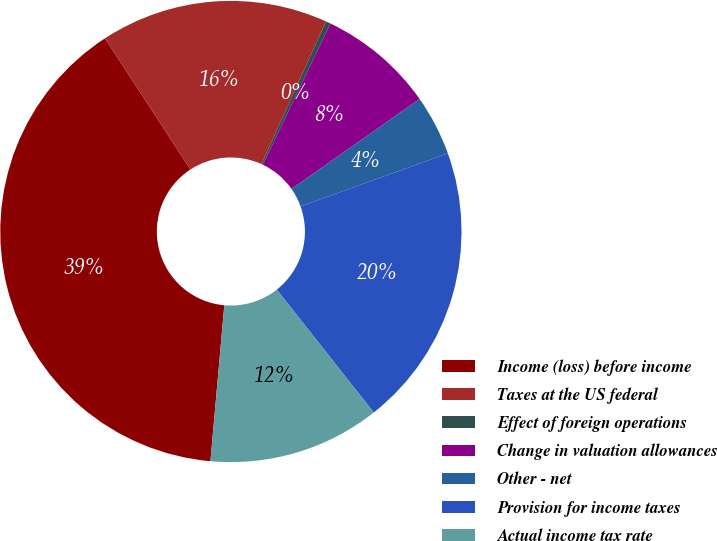Convert chart to OTSL. <chart><loc_0><loc_0><loc_500><loc_500><pie_chart><fcel>Income (loss) before income<fcel>Taxes at the US federal<fcel>Effect of foreign operations<fcel>Change in valuation allowances<fcel>Other - net<fcel>Provision for income taxes<fcel>Actual income tax rate<nl><fcel>39.39%<fcel>15.96%<fcel>0.34%<fcel>8.15%<fcel>4.24%<fcel>19.87%<fcel>12.05%<nl></chart> 